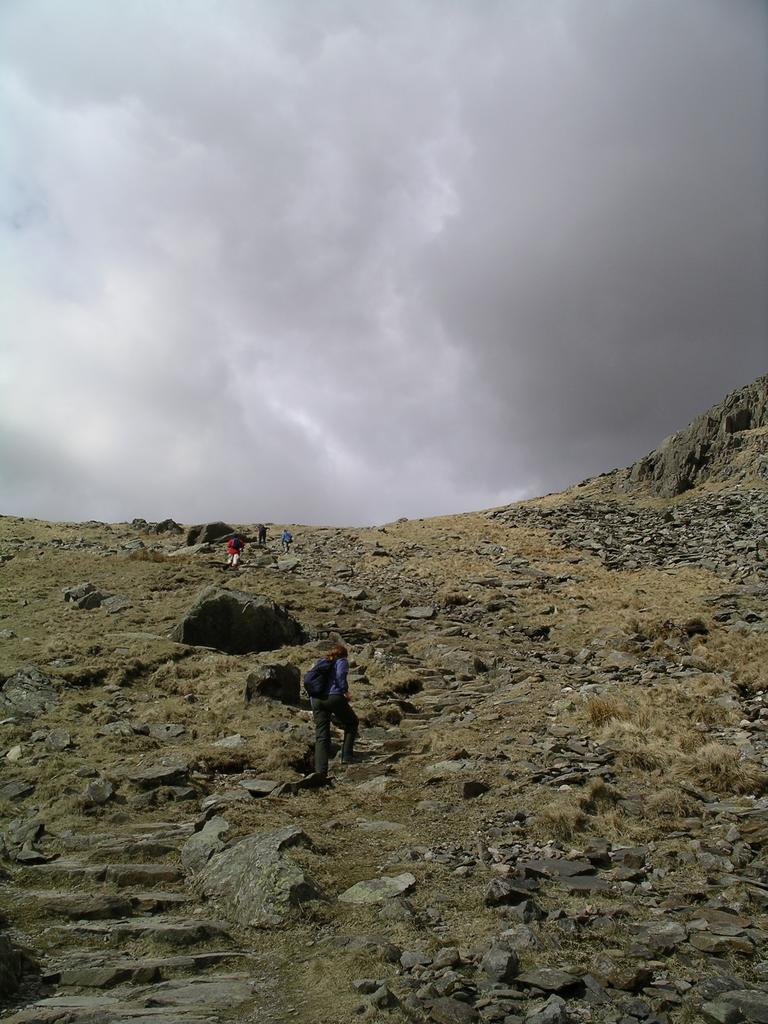Who or what can be seen in the image? There are persons in the image. What are the persons doing in the image? The persons are climbing a hill. What can be seen in the background of the image? There is a sky visible in the background of the image. What is the condition of the sky in the image? Clouds are present in the sky. What type of crime is being committed by the cabbage in the image? There is no cabbage present in the image, and therefore no crime can be committed by it. 